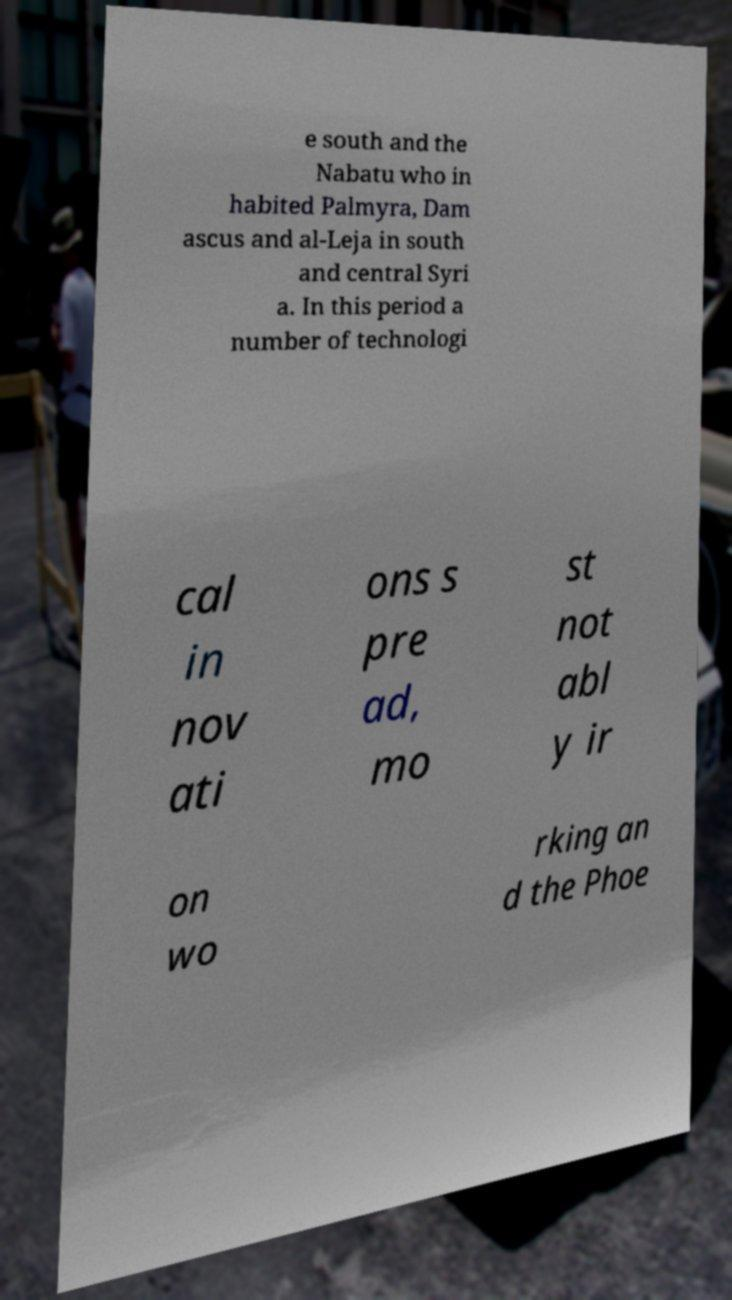There's text embedded in this image that I need extracted. Can you transcribe it verbatim? e south and the Nabatu who in habited Palmyra, Dam ascus and al-Leja in south and central Syri a. In this period a number of technologi cal in nov ati ons s pre ad, mo st not abl y ir on wo rking an d the Phoe 